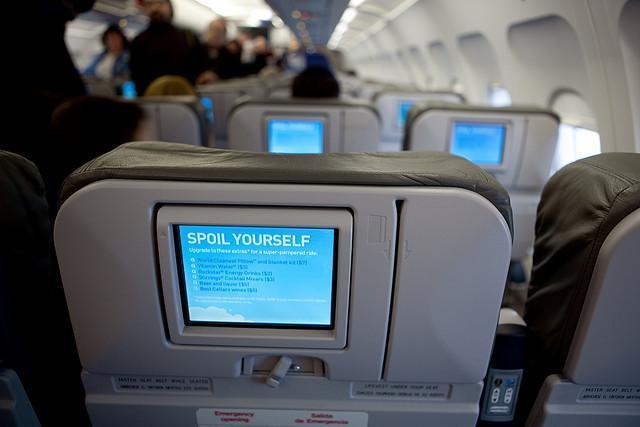How many tvs are there?
Give a very brief answer. 3. How many chairs are visible?
Give a very brief answer. 5. How many people are there?
Give a very brief answer. 2. 